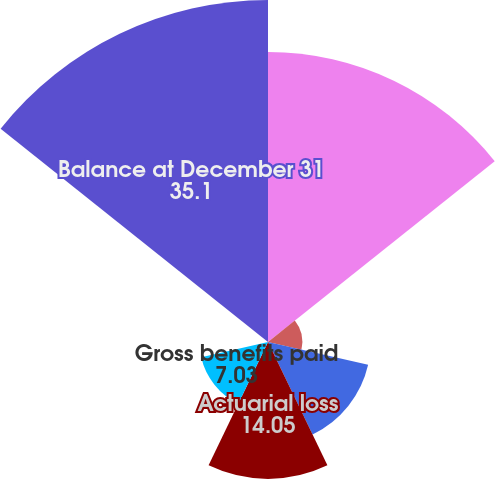Convert chart to OTSL. <chart><loc_0><loc_0><loc_500><loc_500><pie_chart><fcel>Balance at January 1<fcel>Service cost<fcel>Interest cost<fcel>Actuarial loss<fcel>Gross benefits paid<fcel>Other<fcel>Balance at December 31<nl><fcel>29.76%<fcel>3.52%<fcel>10.54%<fcel>14.05%<fcel>7.03%<fcel>0.01%<fcel>35.1%<nl></chart> 